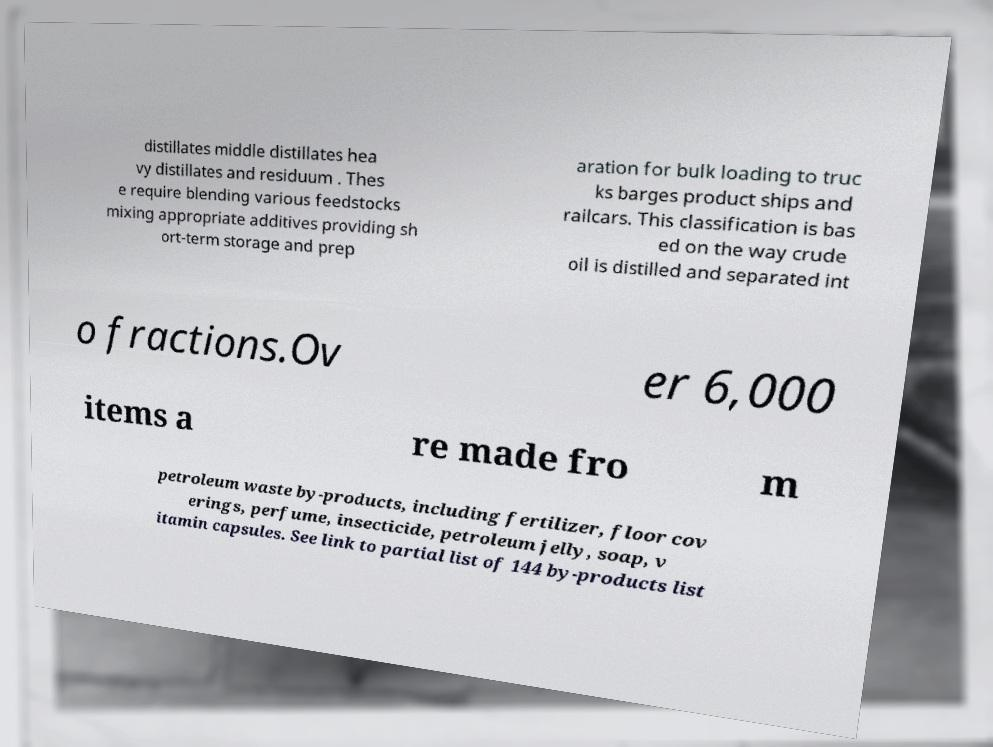Can you read and provide the text displayed in the image?This photo seems to have some interesting text. Can you extract and type it out for me? distillates middle distillates hea vy distillates and residuum . Thes e require blending various feedstocks mixing appropriate additives providing sh ort-term storage and prep aration for bulk loading to truc ks barges product ships and railcars. This classification is bas ed on the way crude oil is distilled and separated int o fractions.Ov er 6,000 items a re made fro m petroleum waste by-products, including fertilizer, floor cov erings, perfume, insecticide, petroleum jelly, soap, v itamin capsules. See link to partial list of 144 by-products list 